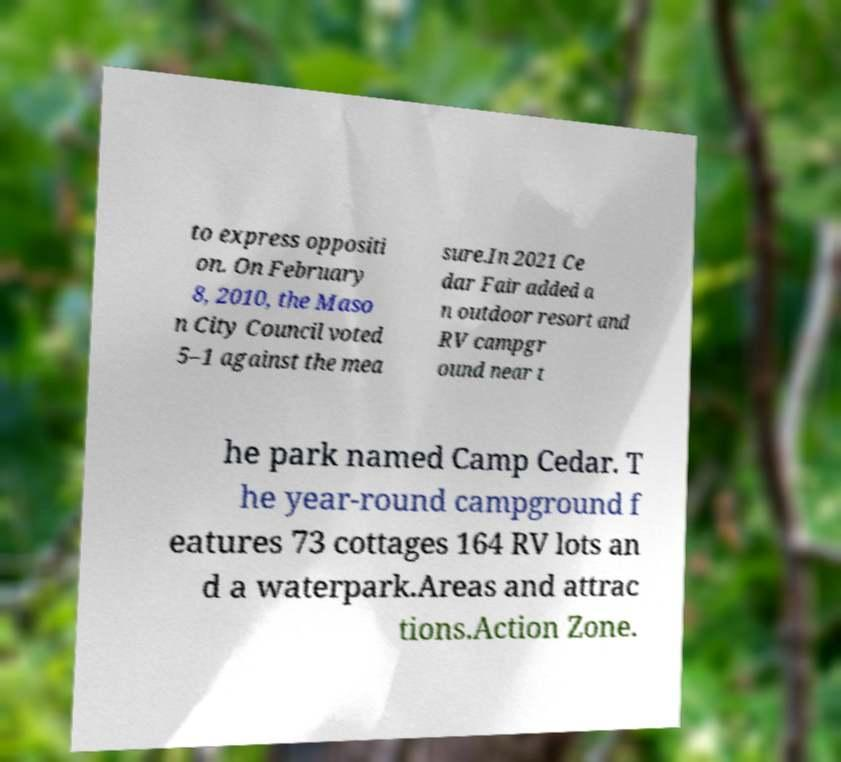There's text embedded in this image that I need extracted. Can you transcribe it verbatim? to express oppositi on. On February 8, 2010, the Maso n City Council voted 5–1 against the mea sure.In 2021 Ce dar Fair added a n outdoor resort and RV campgr ound near t he park named Camp Cedar. T he year-round campground f eatures 73 cottages 164 RV lots an d a waterpark.Areas and attrac tions.Action Zone. 